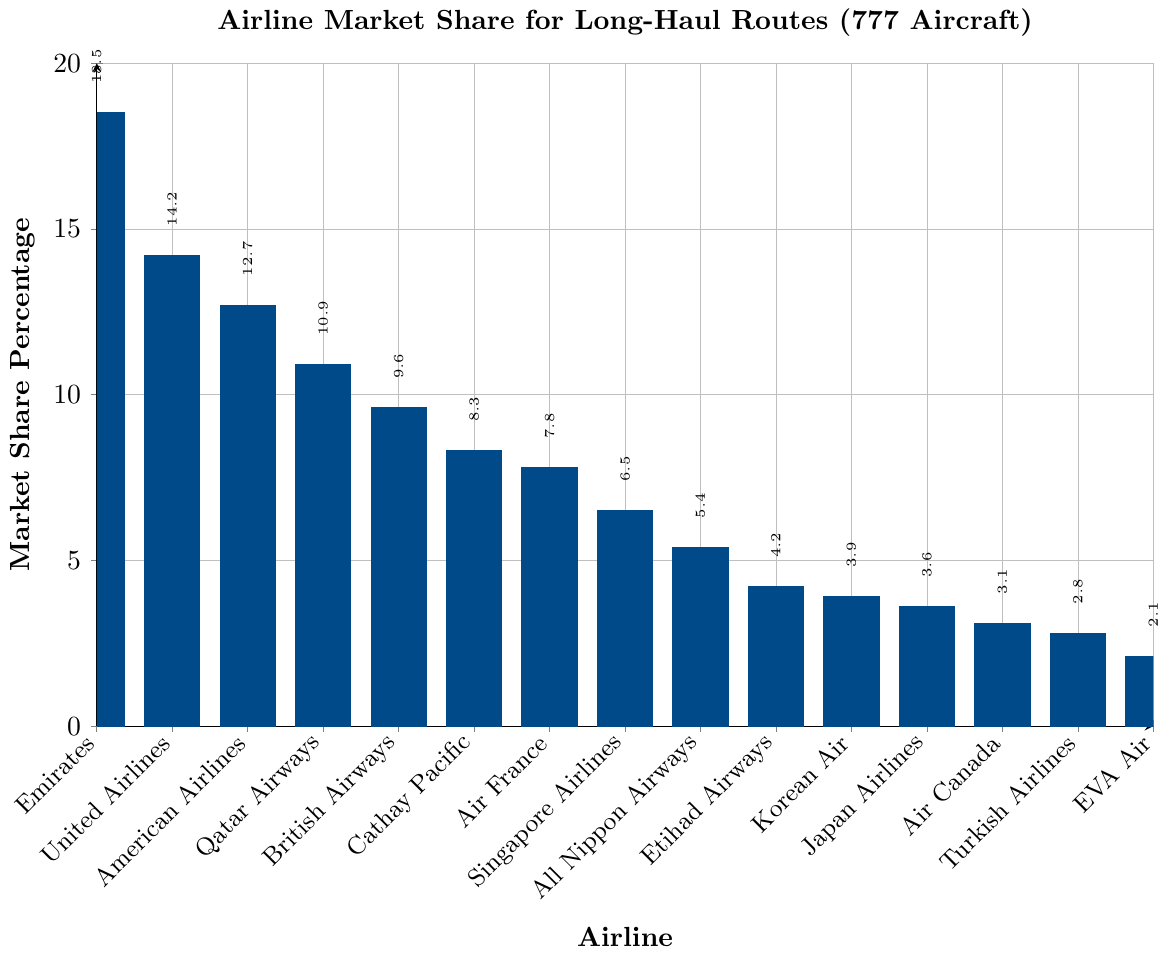Which airline has the highest market share for long-haul routes using 777 aircraft? Looking at the bar chart, the bar for Emirates is the tallest, indicating it has the highest market share.
Answer: Emirates How much greater is Emirates' market share compared to Air France? Emirates has a market share of 18.5%, while Air France has 7.8%. Subtract Air France's share from Emirates' share: 18.5% - 7.8% = 10.7%.
Answer: 10.7% Among British Airways, Cathay Pacific, and All Nippon Airways, which airline has the lowest market share? Compare the heights of the bars for British Airways (9.6%), Cathay Pacific (8.3%), and All Nippon Airways (5.4%). The shortest bar belongs to All Nippon Airways.
Answer: All Nippon Airways What is the combined market share of the three airlines with the smallest market shares? The three airlines with the smallest market shares are EVA Air (2.1%), Turkish Airlines (2.8%), and Air Canada (3.1%). Adding these together: 2.1% + 2.8% + 3.1% = 8.0%.
Answer: 8.0% How does the market share of Qatar Airways compare to that of United Airlines? Qatar Airways has a market share of 10.9%, while United Airlines has 14.2%. United Airlines has a higher market share.
Answer: United Airlines What is the average market share of the top three airlines? The top three airlines are Emirates (18.5%), United Airlines (14.2%), and American Airlines (12.7%). Calculate the average: (18.5% + 14.2% + 12.7%) / 3 = 15.13%.
Answer: 15.13% Which airlines have a market share between 4% and 7%? Observing the bars, the airlines with market shares in this range are Singapore Airlines (6.5%), Etihad Airways (4.2%), and Korean Air (3.9%).
Answer: Singapore Airlines, Etihad Airways, and Korean Air If the sum of the market shares for American Airlines and Qatar Airways is subtracted from Emirates’ market share, what is the result? American Airlines has 12.7%, Qatar Airways has 10.9%, their sum is 12.7% + 10.9% = 23.6%. Subtract this from Emirates’ market share: 18.5% - 23.6% = -5.1%.
Answer: -5.1% How many airlines have a market share greater than 10%? The airlines with market shares greater than 10% are Emirates (18.5%), United Airlines (14.2%), American Airlines (12.7%), and Qatar Airways (10.9%). That makes four airlines.
Answer: Four Compare the market share of Singapore Airlines to that of Cathay Pacific using a ratio. Singapore Airlines has a market share of 6.5%, while Cathay Pacific has 8.3%. The ratio of Singapore Airlines to Cathay Pacific is 6.5% / 8.3% ≈ 0.78.
Answer: 0.78 